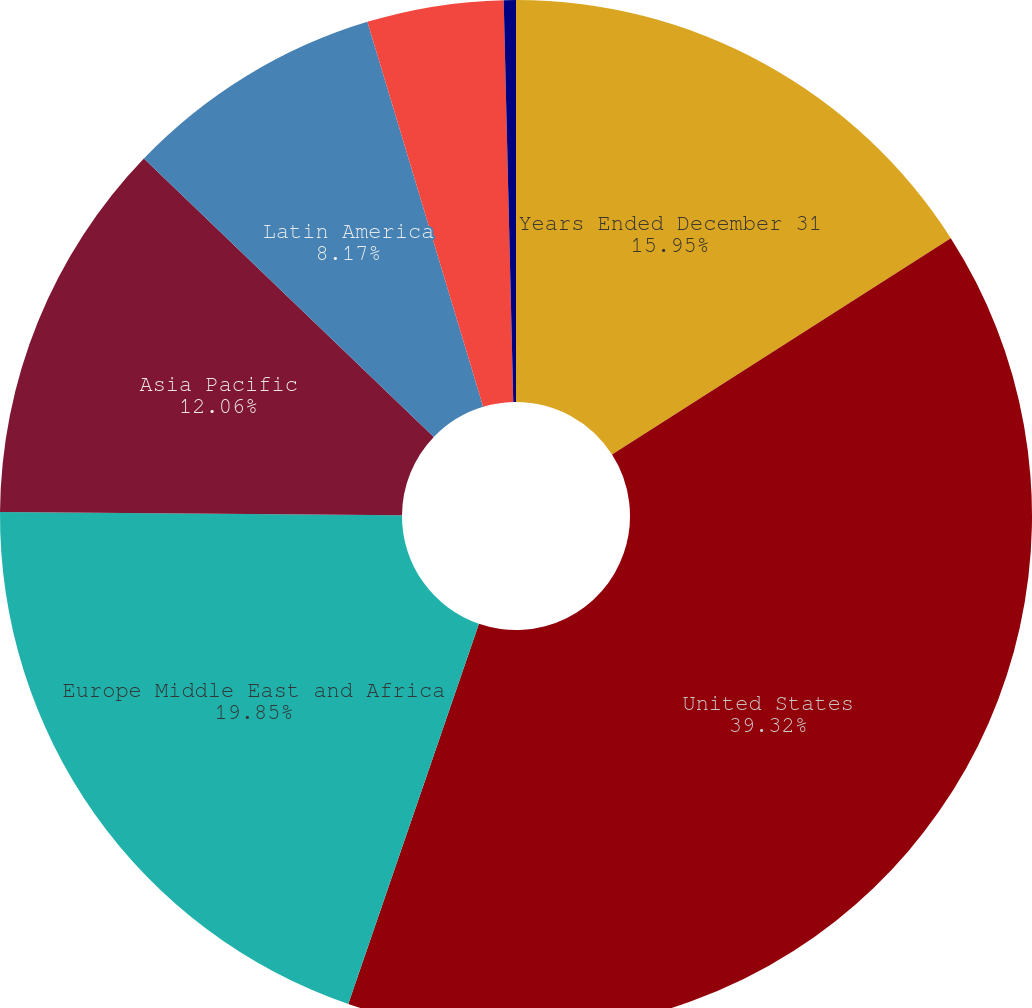<chart> <loc_0><loc_0><loc_500><loc_500><pie_chart><fcel>Years Ended December 31<fcel>United States<fcel>Europe Middle East and Africa<fcel>Asia Pacific<fcel>Latin America<fcel>Japan<fcel>Other<nl><fcel>15.95%<fcel>39.32%<fcel>19.85%<fcel>12.06%<fcel>8.17%<fcel>4.27%<fcel>0.38%<nl></chart> 